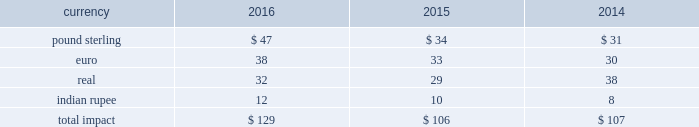Changes in the benchmark index component of the 10-year treasury yield .
The company def signated these derivatives as cash flow hedges .
On october 13 , 2015 , in conjunction with the pricing of the $ 4.5 billion senior notes , the companyr terminated these treasury lock contracts for a cash settlement payment of $ 16 million , which was recorded as a component of other comprehensive earnings and will be reclassified as an adjustment to interest expense over the ten years during which the related interest payments that were hedged will be recognized in income .
Foreign currency risk we are exposed to foreign currency risks that arise from normal business operations .
These risks include the translation of local currency balances of foreign subsidiaries , transaction gains and losses associated with intercompany loans with foreign subsidiaries and transactions denominated in currencies other than a location's functional currency .
We manage the exposure to these risks through a combination of normal operating activities and the use of foreign currency forward contracts .
Contracts are denominated in currtt encies of major industrial countries .
Our exposure to foreign currency exchange risks generally arises from our non-u.s .
Operations , to the extent they are conducted ind local currency .
Changes in foreign currency exchange rates affect translations of revenues denominated in currencies other than the u.s .
Dollar .
During the years ended december 31 , 2016 , 2015 and 2014 , we generated approximately $ 1909 million , $ 1336 million and $ 1229 million , respectively , in revenues denominated in currencies other than the u.s .
Dollar .
The major currencies to which our revenues are exposed are the brazilian real , the euro , the british pound sterling and the indian rupee .
A 10% ( 10 % ) move in average exchange rates for these currencies ( assuming a simultaneous and immediate 10% ( 10 % ) change in all of such rates for the relevant period ) would have resulted in the following increase or ( decrease ) in our reported revenues for the years ended december 31 , 2016 , 2015 and 2014 ( in millions ) : .
While our results of operations have been impacted by the effects of currency fluctuations , our international operations' revenues and expenses are generally denominated in local currency , which reduces our economic exposure to foreign exchange risk in those jurisdictions .
Revenues included $ 100 million and $ 243 million and net earnings included $ 10 million , anrr d $ 31 million , respectively , of unfavorable foreign currency impact during 2016 and 2015 resulting from a stronger u.s .
Dollar during these years compared to thet preceding year .
In 2017 , we expect continued unfavorable foreign currency impact on our operating income resulting from the continued strengthening of the u.s .
Dollar vs .
Other currencies .
Our foreign exchange risk management policy permits the use of derivative instruments , such as forward contracts and options , to reduce volatility in our results of operations and/or cash flows resulting from foreign exchange rate fluctuations .
We do not enter into foreign currency derivative instruments for trading purposes or to engage in speculative activitr y .
We do periodically enter inttt o foreign currency forward exchange contracts to hedge foreign currency exposure to intercompany loans .
As of december 31 , 2016 , the notional amount of these derivatives was approximately $ 143 million and the fair value was nominal .
These derivatives are intended to hedge the foreign exchange risks related to intercompany loans but have not been designated as hedges for accounting purposes .
We also use currency forward contracts to manage our exposure to fluctuations in costs caused by variations in indian rupee ( "inr" ) exchange rates .
As of december 31 , 2016 , the notional amount of these derivatives was approximately $ 7 million and the fair value was ll less than $ 1 million .
These inr forward contracts are designated as cash flow hedges .
The fair value of these currency forward contracts is determined using currency exchange market rates , obtained from reliable , independent , third m party banks , at the balance sheet date .
The fair value of forward contracts is subject to changes in currency exchange rates .
The company has no ineffectiveness related to its use of currency forward contracts in connection with inr cash flow hedges .
In conjunction with entering into the definitive agreement to acquire clear2pay in september 2014 , we initiated a foreign currency forward contract to purchase euros and sell u.s .
Dollars to manage the risk arising from fluctuations in exchange rates until the closing because the purchase price was stated in euros .
As this derivative did not qualify for hedge accounting , we recorded a charge of $ 16 million in other income ( expense ) , net during the third quarter of 2014 .
This forward contract was settled on october 1 , 2014. .
What is the unfavorable foreign currency impact in operating expenses in 2015? 
Computations: (243 - 31)
Answer: 212.0. 